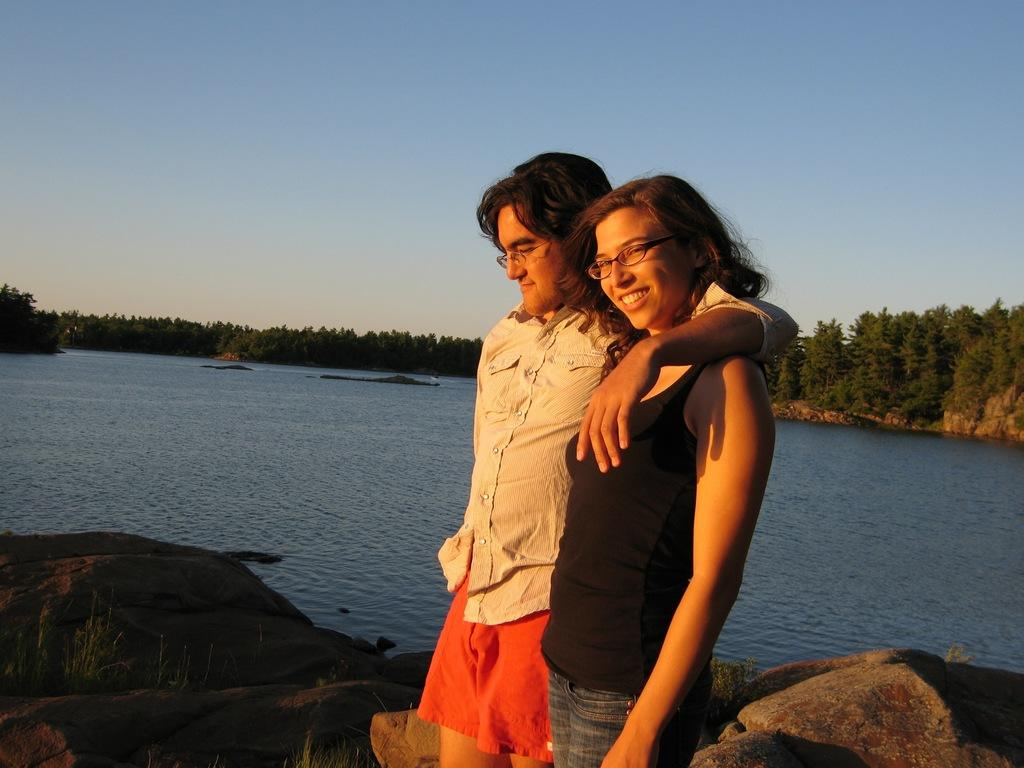Who are the two people in the image? There is a lady and a man standing in the center of the image. What can be seen in the background of the image? There is a river, rocks, and trees visible in the background. What is visible at the top of the image? The sky is visible at the top of the image. What type of behavior do the mice exhibit in the image? There are no mice present in the image, so it is not possible to describe their behavior. 